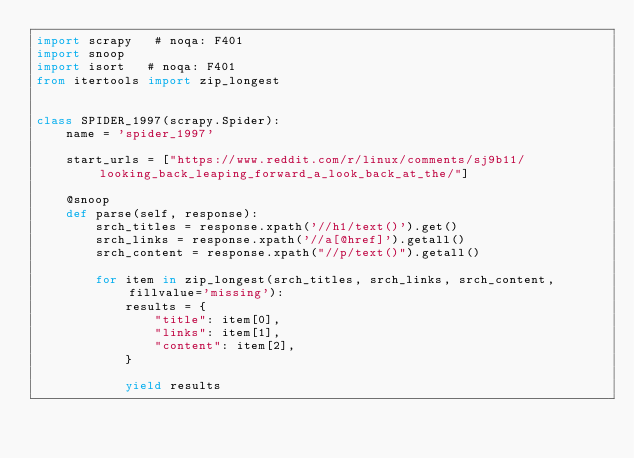<code> <loc_0><loc_0><loc_500><loc_500><_Python_>import scrapy   # noqa: F401
import snoop
import isort   # noqa: F401
from itertools import zip_longest


class SPIDER_1997(scrapy.Spider):
    name = 'spider_1997'

    start_urls = ["https://www.reddit.com/r/linux/comments/sj9b11/looking_back_leaping_forward_a_look_back_at_the/"]

    @snoop
    def parse(self, response):
        srch_titles = response.xpath('//h1/text()').get()
        srch_links = response.xpath('//a[@href]').getall()
        srch_content = response.xpath("//p/text()").getall()

        for item in zip_longest(srch_titles, srch_links, srch_content, fillvalue='missing'):
            results = {
                "title": item[0],
                "links": item[1],
                "content": item[2],
            }

            yield results
                   </code> 